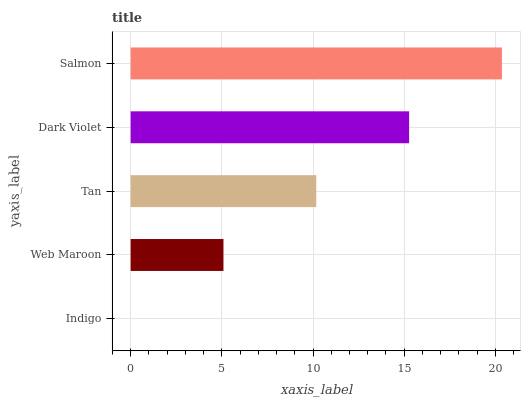Is Indigo the minimum?
Answer yes or no. Yes. Is Salmon the maximum?
Answer yes or no. Yes. Is Web Maroon the minimum?
Answer yes or no. No. Is Web Maroon the maximum?
Answer yes or no. No. Is Web Maroon greater than Indigo?
Answer yes or no. Yes. Is Indigo less than Web Maroon?
Answer yes or no. Yes. Is Indigo greater than Web Maroon?
Answer yes or no. No. Is Web Maroon less than Indigo?
Answer yes or no. No. Is Tan the high median?
Answer yes or no. Yes. Is Tan the low median?
Answer yes or no. Yes. Is Dark Violet the high median?
Answer yes or no. No. Is Web Maroon the low median?
Answer yes or no. No. 